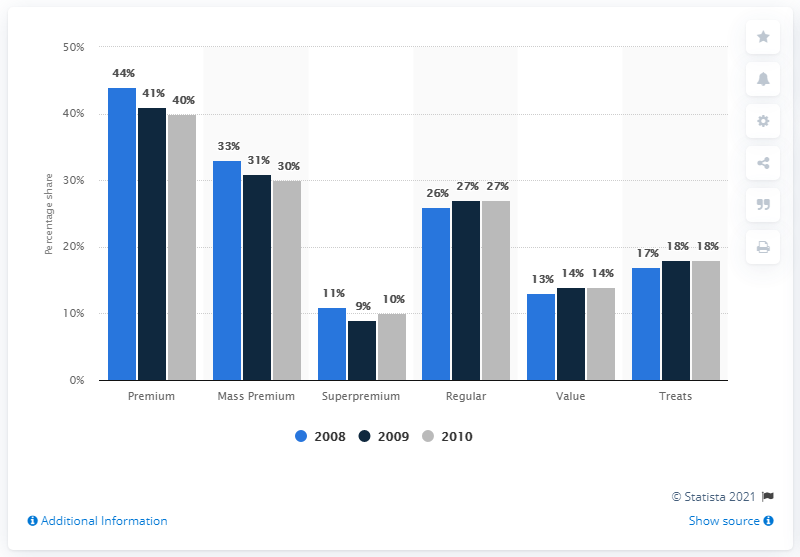What is the total percentage of share of retail sales of dog and cat food in regular? Based on the provided bar chart, the total percentage share of retail sales for dog and cat food in the 'Regular' category for the years 2008, 2009, and 2010 are 26%, 27%, and 27% respectively. However, without additional context such as the specific year requested or a range of years to calculate an average, a single total percentage figure cannot be accurately provided. 